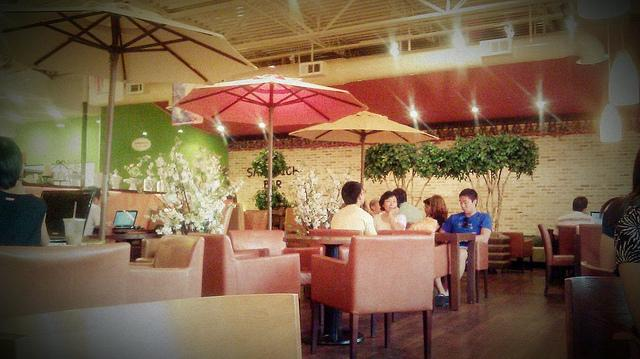What type of restaurant does this appear to be? Please explain your reasoning. asian. This seems to be the case based on the customers. 